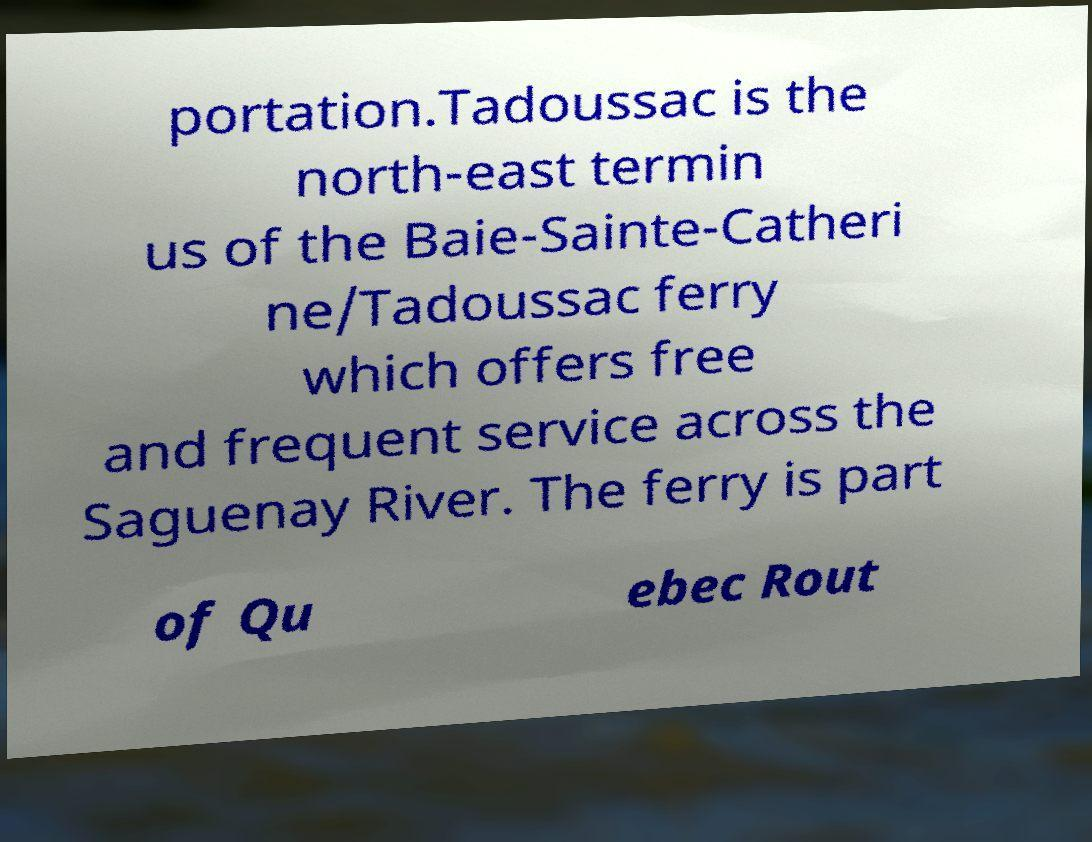I need the written content from this picture converted into text. Can you do that? portation.Tadoussac is the north-east termin us of the Baie-Sainte-Catheri ne/Tadoussac ferry which offers free and frequent service across the Saguenay River. The ferry is part of Qu ebec Rout 